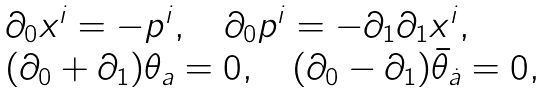Convert formula to latex. <formula><loc_0><loc_0><loc_500><loc_500>\begin{array} { l } { { \partial _ { 0 } x ^ { i } = - p ^ { i } , \quad \partial _ { 0 } p ^ { i } = - \partial _ { 1 } \partial _ { 1 } x ^ { i } , } } \\ { { ( \partial _ { 0 } + \partial _ { 1 } ) \theta _ { a } = 0 , \quad ( \partial _ { 0 } - \partial _ { 1 } ) \bar { \theta } _ { \dot { a } } = 0 , } } \end{array}</formula> 